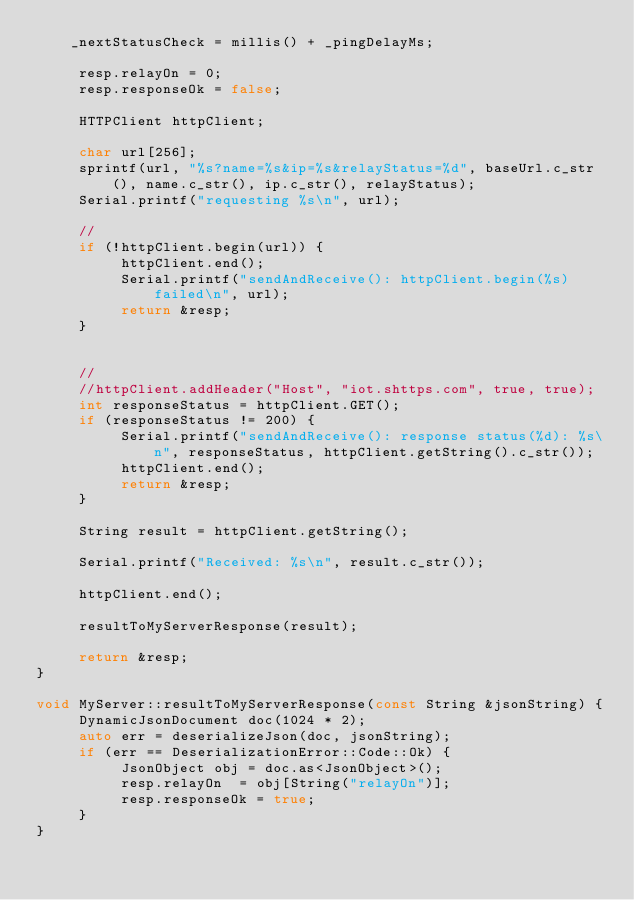<code> <loc_0><loc_0><loc_500><loc_500><_C++_>    _nextStatusCheck = millis() + _pingDelayMs;

     resp.relayOn = 0;
     resp.responseOk = false;

     HTTPClient httpClient;

     char url[256];
     sprintf(url, "%s?name=%s&ip=%s&relayStatus=%d", baseUrl.c_str(), name.c_str(), ip.c_str(), relayStatus);
     Serial.printf("requesting %s\n", url);

     //
     if (!httpClient.begin(url)) {
          httpClient.end();
          Serial.printf("sendAndReceive(): httpClient.begin(%s) failed\n", url);
          return &resp;
     }


     //
     //httpClient.addHeader("Host", "iot.shttps.com", true, true);
     int responseStatus = httpClient.GET();
     if (responseStatus != 200) {
          Serial.printf("sendAndReceive(): response status(%d): %s\n", responseStatus, httpClient.getString().c_str());
          httpClient.end();
          return &resp;
     }

     String result = httpClient.getString();

     Serial.printf("Received: %s\n", result.c_str());

     httpClient.end();

     resultToMyServerResponse(result);

     return &resp;
}

void MyServer::resultToMyServerResponse(const String &jsonString) {
     DynamicJsonDocument doc(1024 * 2);
     auto err = deserializeJson(doc, jsonString);
     if (err == DeserializationError::Code::Ok) {
          JsonObject obj = doc.as<JsonObject>();
          resp.relayOn  = obj[String("relayOn")];
          resp.responseOk = true;
     }
}</code> 